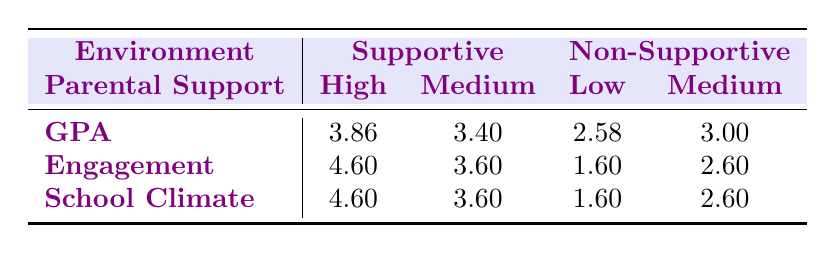What is the GPA for transgender teens in high supportive environments? According to the table, the GPA for the high parental support group under supportive environments is listed as 3.86.
Answer: 3.86 What is the lowest engagement score recorded for non-supportive environments? The table shows that the lowest engagement score in non-supportive environments is 1.60, which occurs under both low and medium parental support.
Answer: 1.60 What is the difference in average GPA between high supportive and low non-supportive environments? The average GPA for high supportive environments is 3.86, and for low non-supportive environments, it is 2.58. The difference is calculated as 3.86 - 2.58 = 1.28.
Answer: 1.28 Is the average school climate score higher in supportive or non-supportive environments? For supportive environments, the average school climate score is 4.60, while for non-supportive environments, it is 1.60. Since 4.60 is greater than 1.60, the supportive environments have a higher average score.
Answer: Yes What is the average GPAs for medium supportive and medium non-supportive environments, and which one is higher? The average GPA for medium supportive environments is 3.40, and for medium non-supportive environments, it is 3.00. 3.40 is greater than 3.00, indicating the medium supportive environment has a higher GPA.
Answer: Medium supportive is higher What is the average engagement score across all supportive environments? To find the average engagement score for supportive environments, we calculate the mean of both high (4.60) and medium (3.60) scores: (4.60 + 3.60) / 2 = 4.10.
Answer: 4.10 Which environment has a higher average school climate score, supportive or non-supportive? By examining the table, the average school climate score for supportive environments is 4.60, while for non-supportive environments, it is 1.60. Since 4.60 is greater than 1.60, supportive environments have a higher score.
Answer: Supportive What is the total score (sum) of engagement from all groups? The total score can be calculated by adding the engagement scores from all groups: 4.60 (high supportive) + 3.60 (medium supportive) + 1.60 (low non-supportive) + 2.60 (medium non-supportive) = 12.40.
Answer: 12.40 